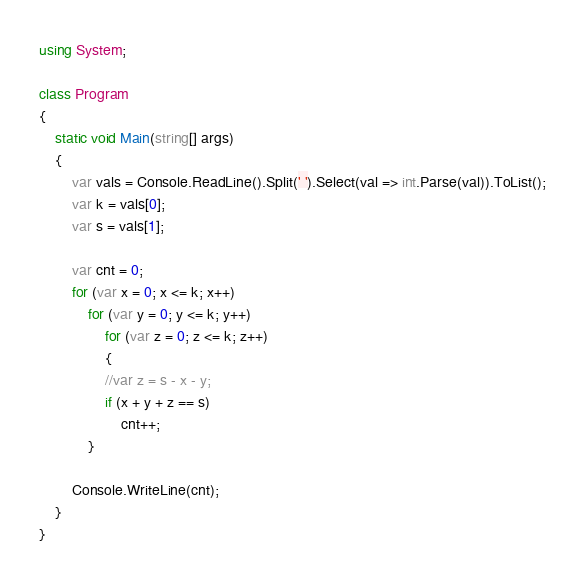Convert code to text. <code><loc_0><loc_0><loc_500><loc_500><_C#_>using System;

class Program
{
    static void Main(string[] args)
    {
        var vals = Console.ReadLine().Split(' ').Select(val => int.Parse(val)).ToList();
        var k = vals[0];
        var s = vals[1];

        var cnt = 0;
        for (var x = 0; x <= k; x++)
            for (var y = 0; y <= k; y++)
                for (var z = 0; z <= k; z++)
                {
                //var z = s - x - y;
                if (x + y + z == s)
                    cnt++;
            }

        Console.WriteLine(cnt);
    }
}</code> 